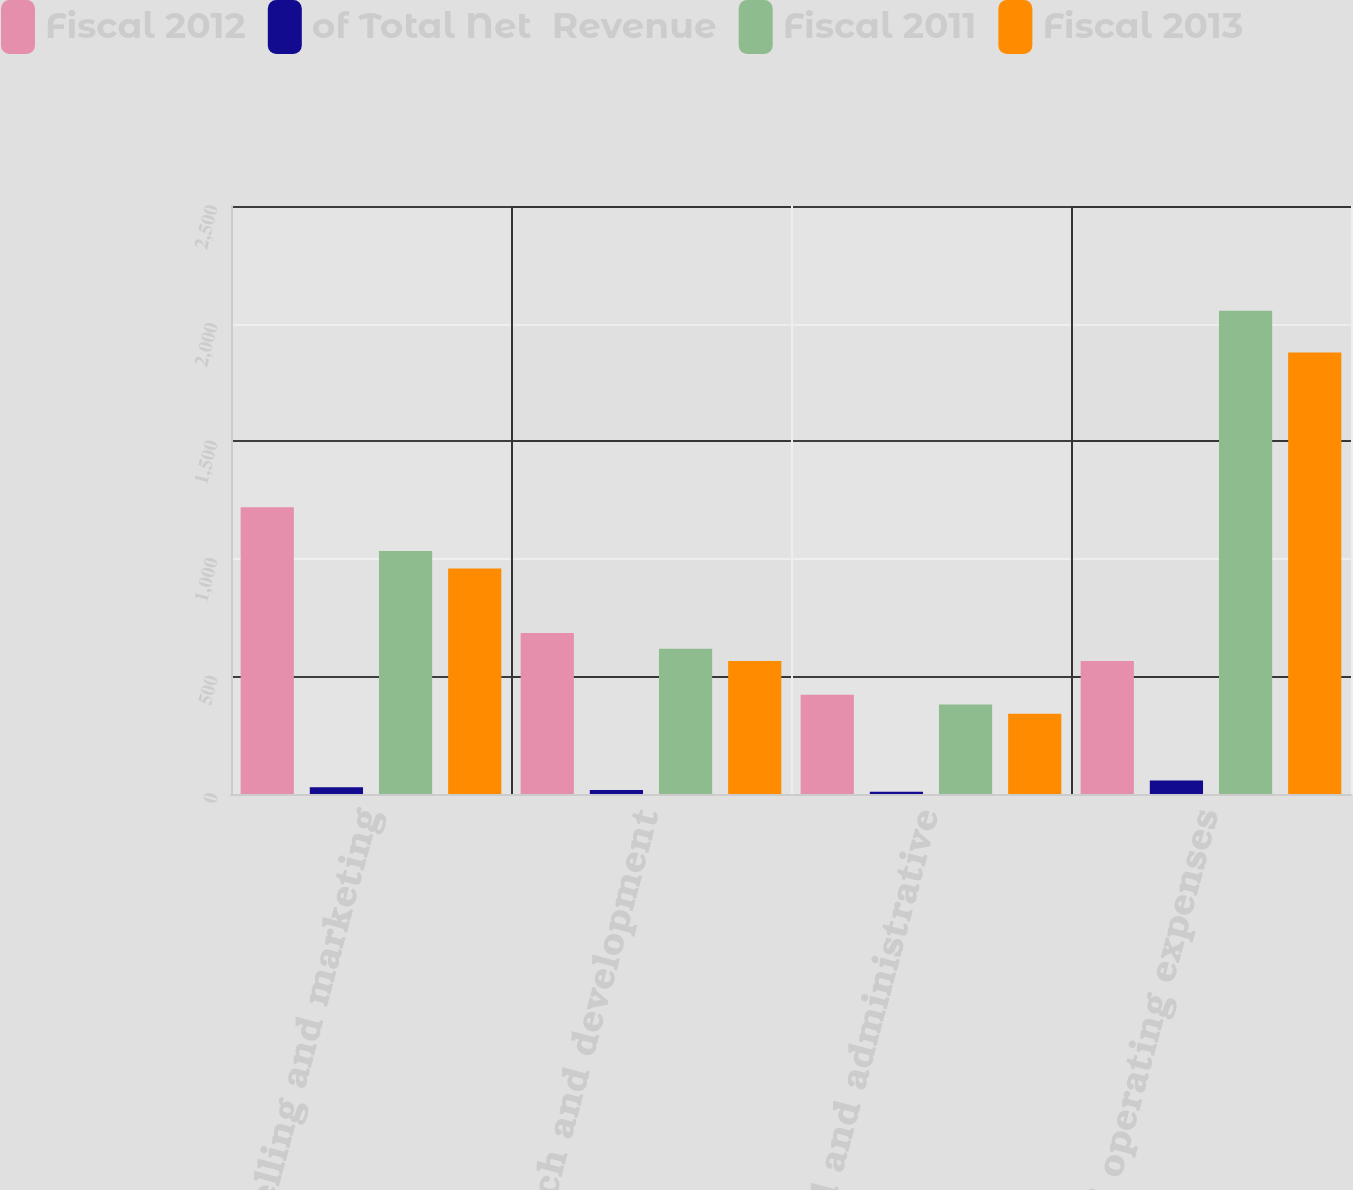Convert chart. <chart><loc_0><loc_0><loc_500><loc_500><stacked_bar_chart><ecel><fcel>Selling and marketing<fcel>Research and development<fcel>General and administrative<fcel>Total operating expenses<nl><fcel>Fiscal 2012<fcel>1219<fcel>685<fcel>422<fcel>566<nl><fcel>of Total Net  Revenue<fcel>29<fcel>17<fcel>10<fcel>57<nl><fcel>Fiscal 2011<fcel>1033<fcel>618<fcel>381<fcel>2055<nl><fcel>Fiscal 2013<fcel>959<fcel>566<fcel>341<fcel>1877<nl></chart> 